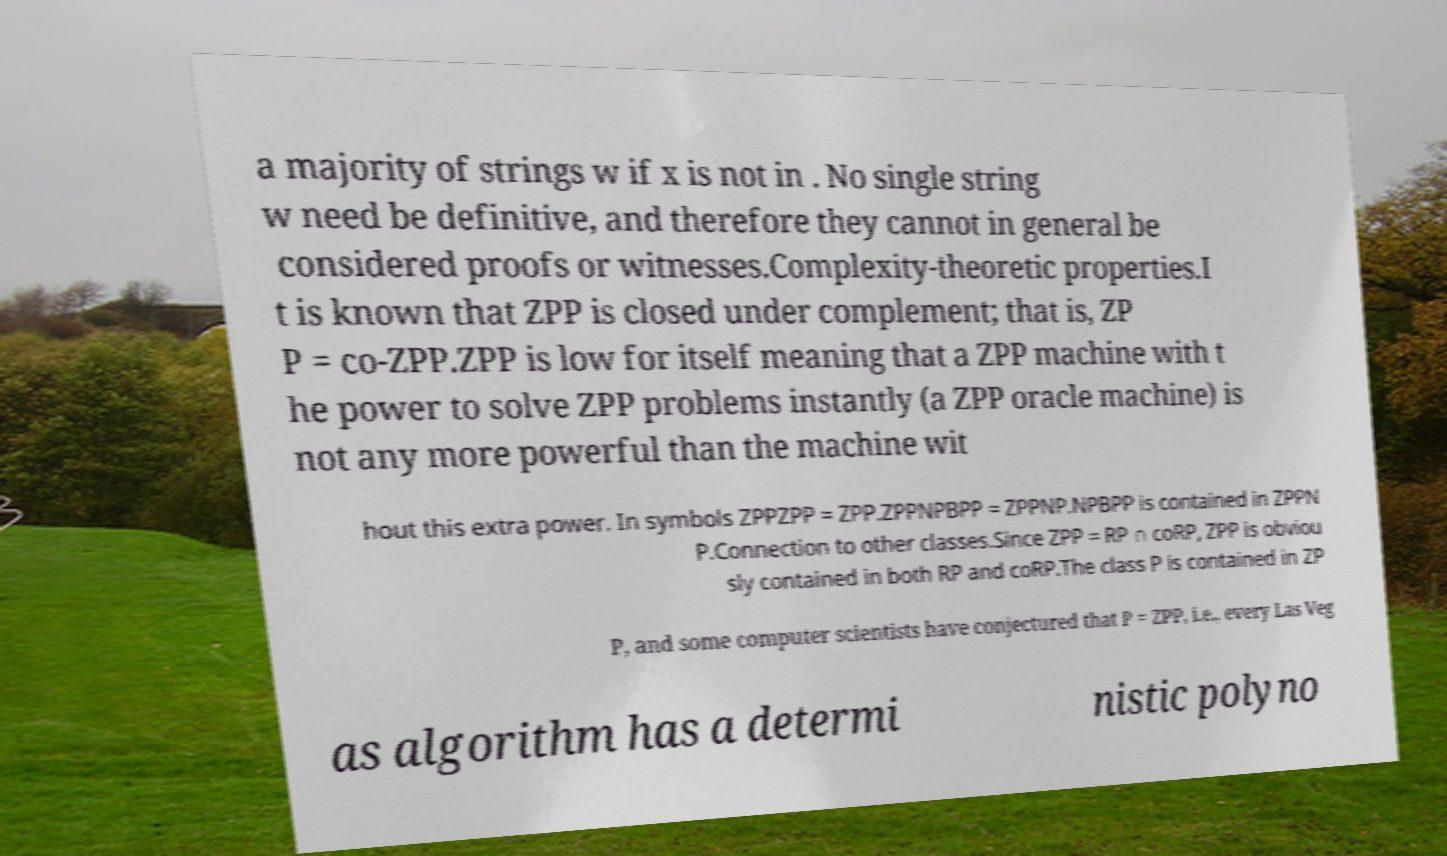Can you accurately transcribe the text from the provided image for me? a majority of strings w if x is not in . No single string w need be definitive, and therefore they cannot in general be considered proofs or witnesses.Complexity-theoretic properties.I t is known that ZPP is closed under complement; that is, ZP P = co-ZPP.ZPP is low for itself meaning that a ZPP machine with t he power to solve ZPP problems instantly (a ZPP oracle machine) is not any more powerful than the machine wit hout this extra power. In symbols ZPPZPP = ZPP.ZPPNPBPP = ZPPNP.NPBPP is contained in ZPPN P.Connection to other classes.Since ZPP = RP ∩ coRP, ZPP is obviou sly contained in both RP and coRP.The class P is contained in ZP P, and some computer scientists have conjectured that P = ZPP, i.e., every Las Veg as algorithm has a determi nistic polyno 